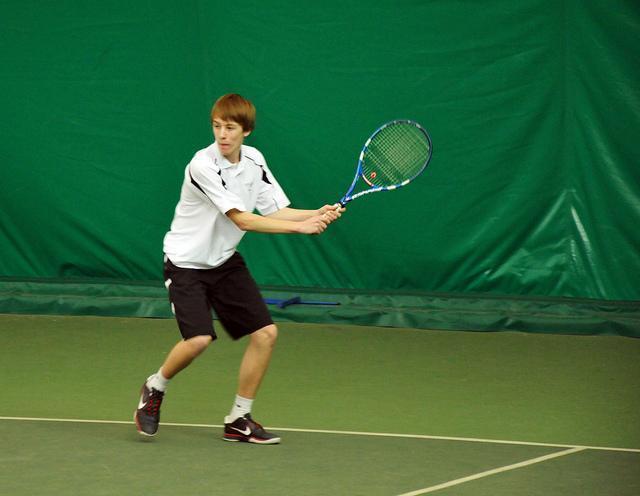How many hands is he holding the racket with?
Give a very brief answer. 2. How many tennis rackets are there?
Give a very brief answer. 1. 